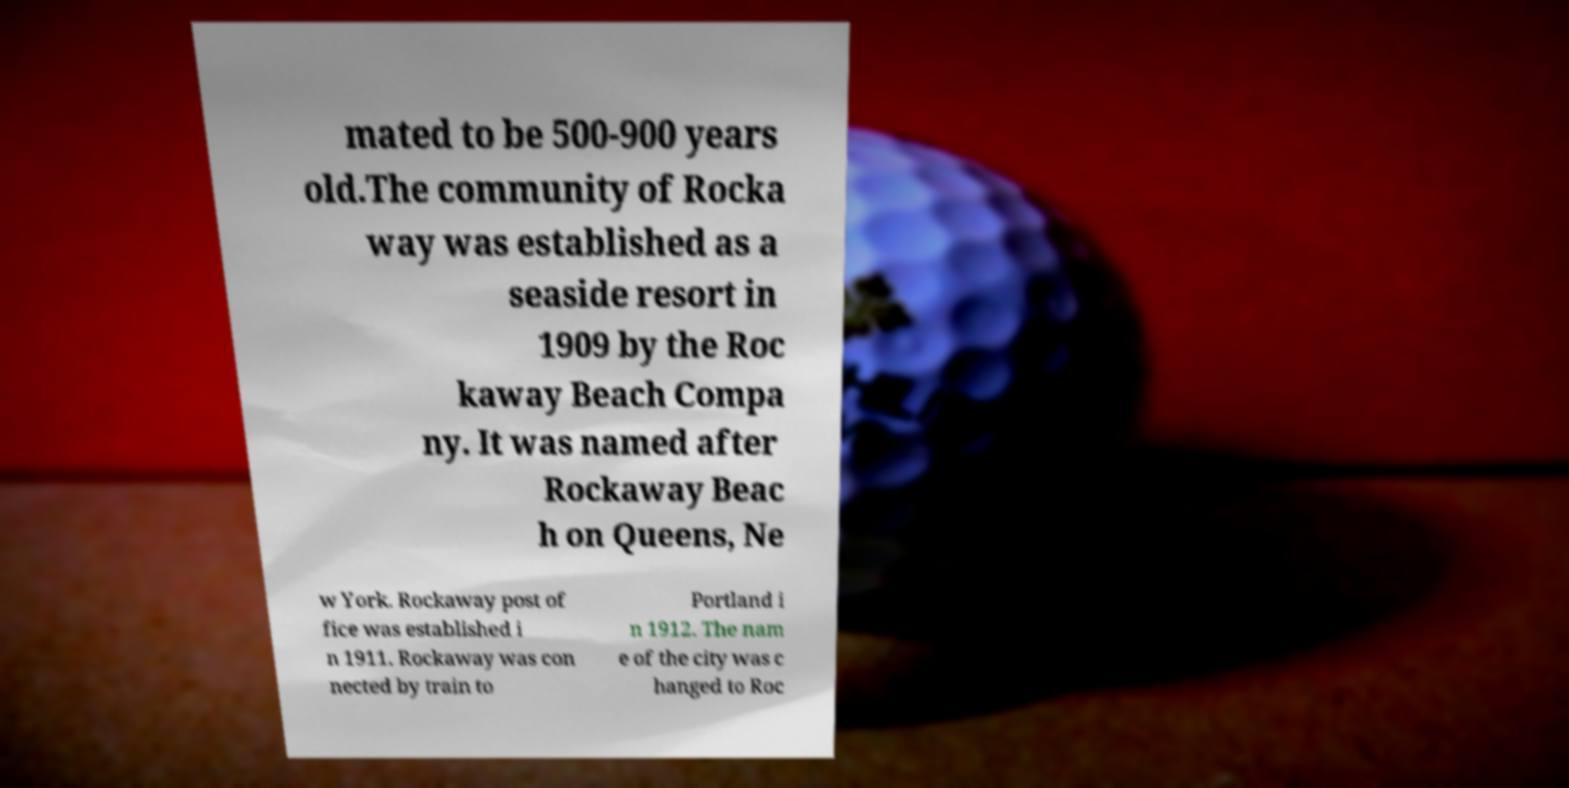For documentation purposes, I need the text within this image transcribed. Could you provide that? mated to be 500-900 years old.The community of Rocka way was established as a seaside resort in 1909 by the Roc kaway Beach Compa ny. It was named after Rockaway Beac h on Queens, Ne w York. Rockaway post of fice was established i n 1911. Rockaway was con nected by train to Portland i n 1912. The nam e of the city was c hanged to Roc 